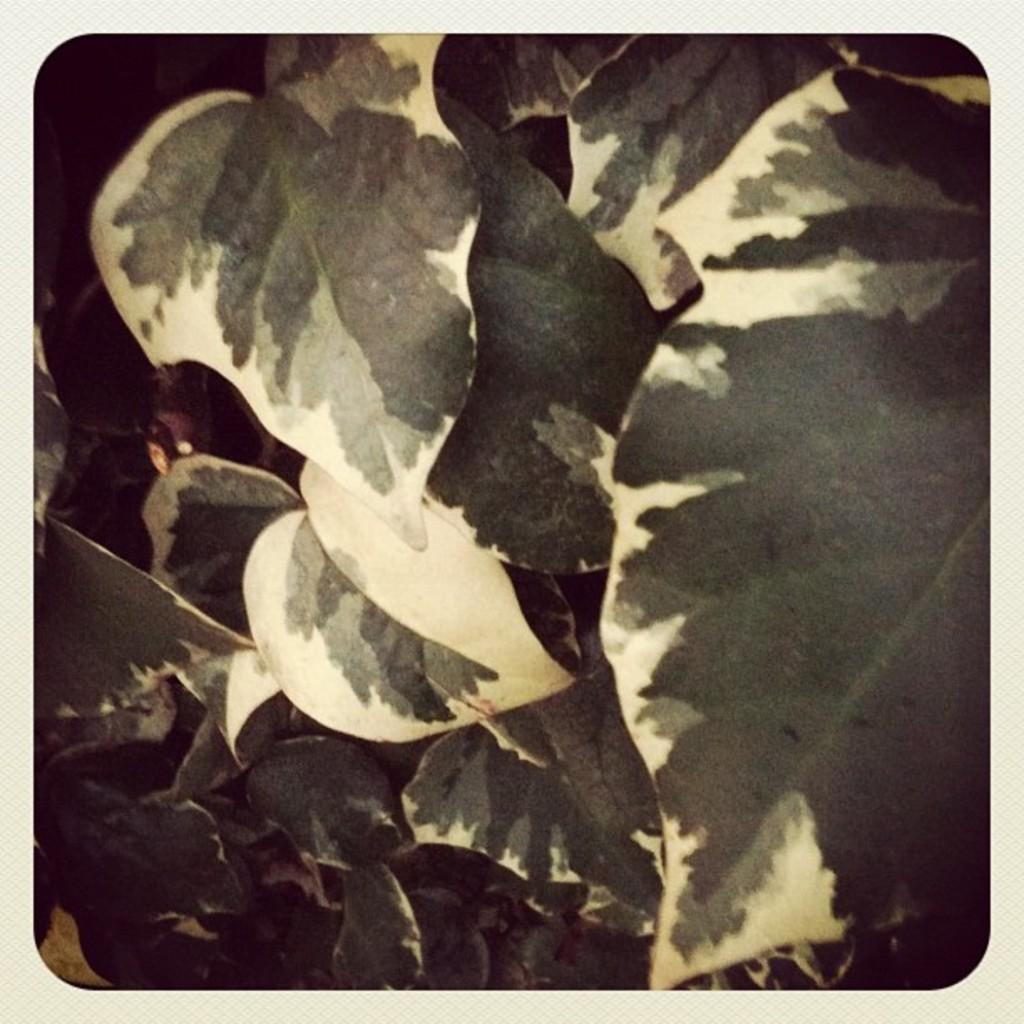What is the main subject of the image? There is a photo in the image. Can you describe the photo's appearance? The photo has a frame border. What else can be seen in the image besides the photo? There are leaves visible in the image. What arithmetic problem is being solved in the image? There is no arithmetic problem present in the image; it features a photo with a frame border and leaves. 